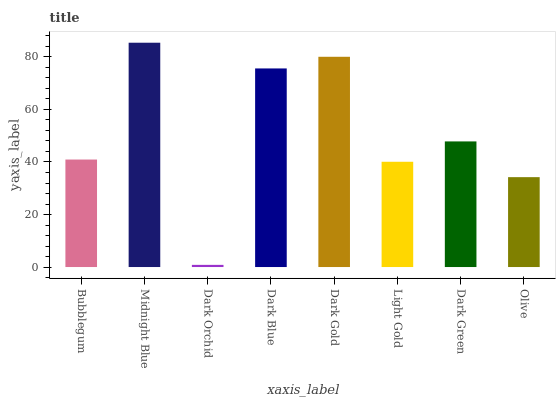Is Dark Orchid the minimum?
Answer yes or no. Yes. Is Midnight Blue the maximum?
Answer yes or no. Yes. Is Midnight Blue the minimum?
Answer yes or no. No. Is Dark Orchid the maximum?
Answer yes or no. No. Is Midnight Blue greater than Dark Orchid?
Answer yes or no. Yes. Is Dark Orchid less than Midnight Blue?
Answer yes or no. Yes. Is Dark Orchid greater than Midnight Blue?
Answer yes or no. No. Is Midnight Blue less than Dark Orchid?
Answer yes or no. No. Is Dark Green the high median?
Answer yes or no. Yes. Is Bubblegum the low median?
Answer yes or no. Yes. Is Dark Gold the high median?
Answer yes or no. No. Is Dark Green the low median?
Answer yes or no. No. 